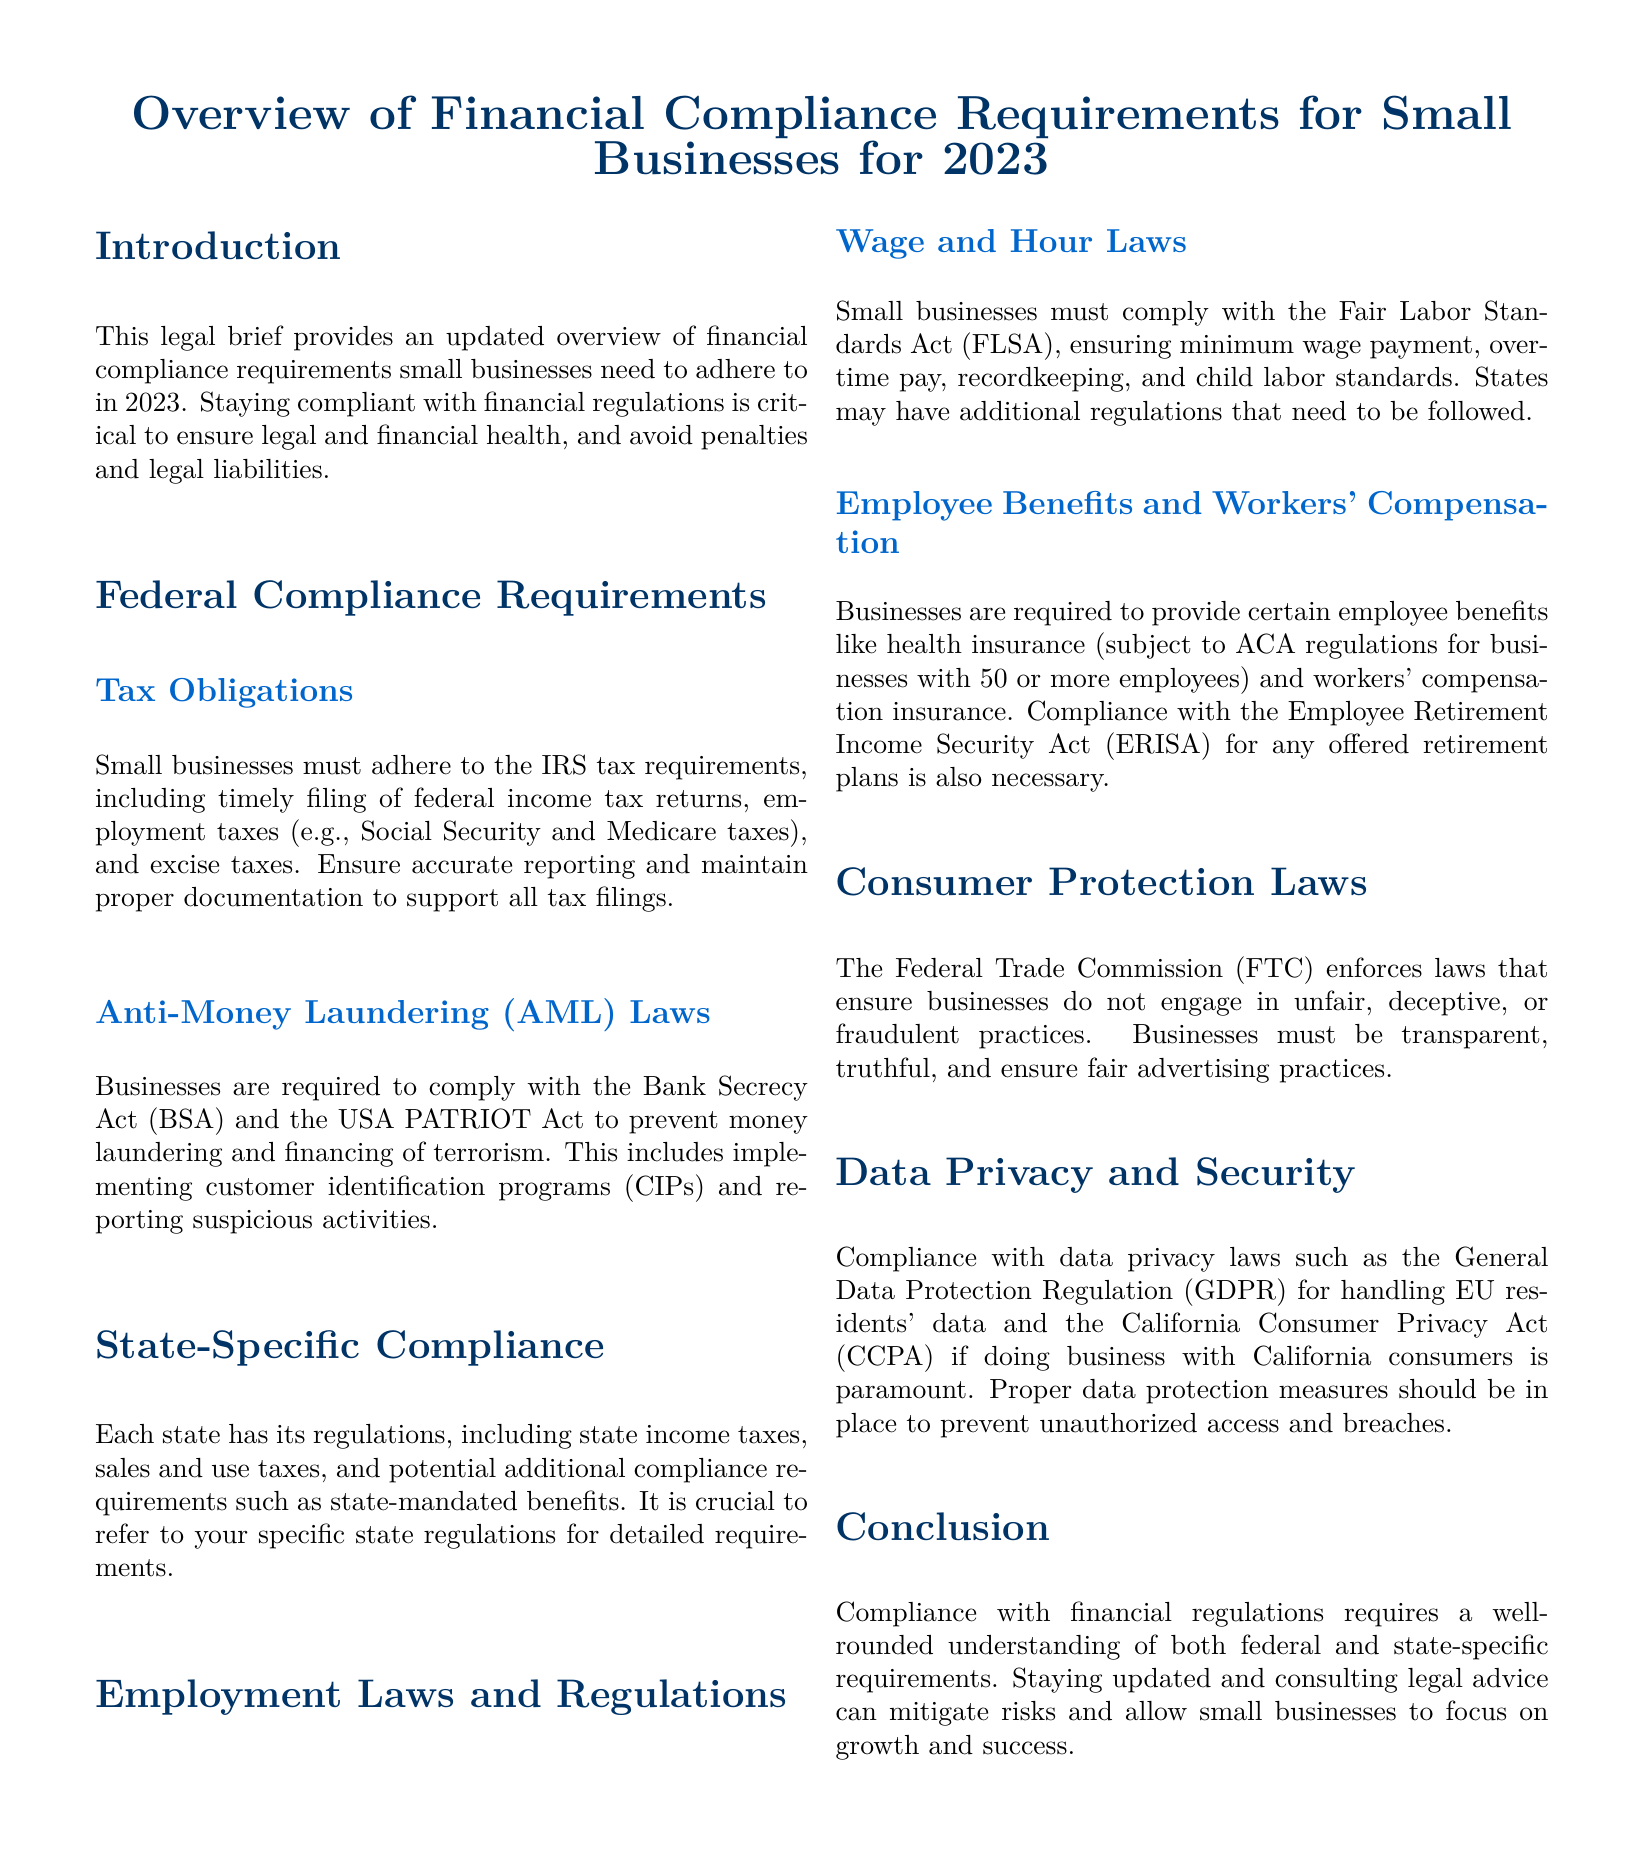What is the title of the document? The title of the document is stated in the header section, highlighting the primary focus of the brief.
Answer: Overview of Financial Compliance Requirements for Small Businesses for 2023 What act ensures minimum wage payment? This act is identified within the Employment Laws section of the document, detailing wage and hour compliance.
Answer: Fair Labor Standards Act (FLSA) What is required for Anti-Money Laundering compliance? The document specifies that compliance involves implementing programs and reporting activities, particularly mandated by specific legislation.
Answer: Customer Identification Programs (CIPs) What must businesses comply with regarding consumer protection? The requirement is related to laws enforced to maintain fair practices in business operations, specifically regarding how they treat consumers.
Answer: Federal Trade Commission (FTC) What is the main tax obligation for small businesses? The primary obligation mentioned is related to federal income and employment taxes, which are crucial for financial compliance.
Answer: Timely filing of federal income tax returns What is the required insurance for employees in small businesses? This information pertains to mandatory employee protections highlighted under employment laws to ensure safe working conditions.
Answer: Workers' compensation insurance How does the document suggest small businesses mitigate compliance risks? The conclusion emphasizes ensuring that businesses stay informed and seek professional advice for compliance matters.
Answer: Consult legal advice What state compliance aspect is highlighted in the document? The document reviews a specific area of regulation that varies by location, underscoring the necessity for localized awareness.
Answer: State income taxes What type of data protection law is mentioned for EU residents? The document categorizes specific regulations that need to be adhered to when dealing with personal data across borders.
Answer: General Data Protection Regulation (GDPR) 